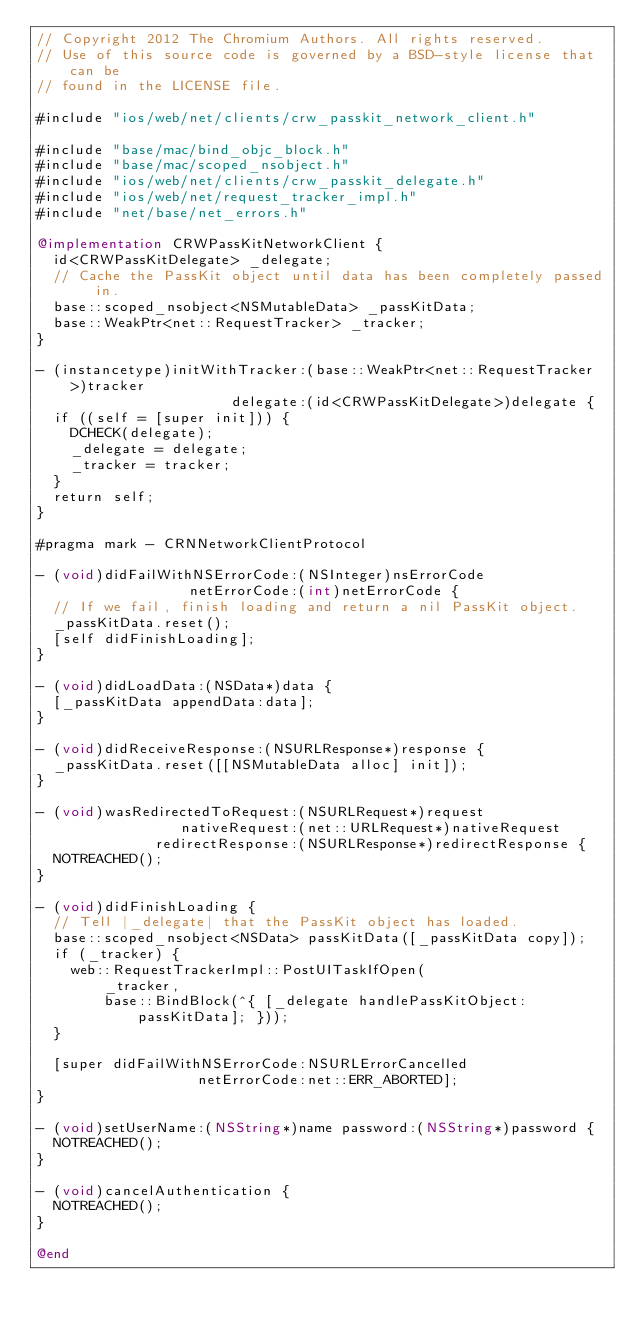<code> <loc_0><loc_0><loc_500><loc_500><_ObjectiveC_>// Copyright 2012 The Chromium Authors. All rights reserved.
// Use of this source code is governed by a BSD-style license that can be
// found in the LICENSE file.

#include "ios/web/net/clients/crw_passkit_network_client.h"

#include "base/mac/bind_objc_block.h"
#include "base/mac/scoped_nsobject.h"
#include "ios/web/net/clients/crw_passkit_delegate.h"
#include "ios/web/net/request_tracker_impl.h"
#include "net/base/net_errors.h"

@implementation CRWPassKitNetworkClient {
  id<CRWPassKitDelegate> _delegate;
  // Cache the PassKit object until data has been completely passed in.
  base::scoped_nsobject<NSMutableData> _passKitData;
  base::WeakPtr<net::RequestTracker> _tracker;
}

- (instancetype)initWithTracker:(base::WeakPtr<net::RequestTracker>)tracker
                       delegate:(id<CRWPassKitDelegate>)delegate {
  if ((self = [super init])) {
    DCHECK(delegate);
    _delegate = delegate;
    _tracker = tracker;
  }
  return self;
}

#pragma mark - CRNNetworkClientProtocol

- (void)didFailWithNSErrorCode:(NSInteger)nsErrorCode
                  netErrorCode:(int)netErrorCode {
  // If we fail, finish loading and return a nil PassKit object.
  _passKitData.reset();
  [self didFinishLoading];
}

- (void)didLoadData:(NSData*)data {
  [_passKitData appendData:data];
}

- (void)didReceiveResponse:(NSURLResponse*)response {
  _passKitData.reset([[NSMutableData alloc] init]);
}

- (void)wasRedirectedToRequest:(NSURLRequest*)request
                 nativeRequest:(net::URLRequest*)nativeRequest
              redirectResponse:(NSURLResponse*)redirectResponse {
  NOTREACHED();
}

- (void)didFinishLoading {
  // Tell |_delegate| that the PassKit object has loaded.
  base::scoped_nsobject<NSData> passKitData([_passKitData copy]);
  if (_tracker) {
    web::RequestTrackerImpl::PostUITaskIfOpen(
        _tracker,
        base::BindBlock(^{ [_delegate handlePassKitObject:passKitData]; }));
  }

  [super didFailWithNSErrorCode:NSURLErrorCancelled
                   netErrorCode:net::ERR_ABORTED];
}

- (void)setUserName:(NSString*)name password:(NSString*)password {
  NOTREACHED();
}

- (void)cancelAuthentication {
  NOTREACHED();
}

@end
</code> 